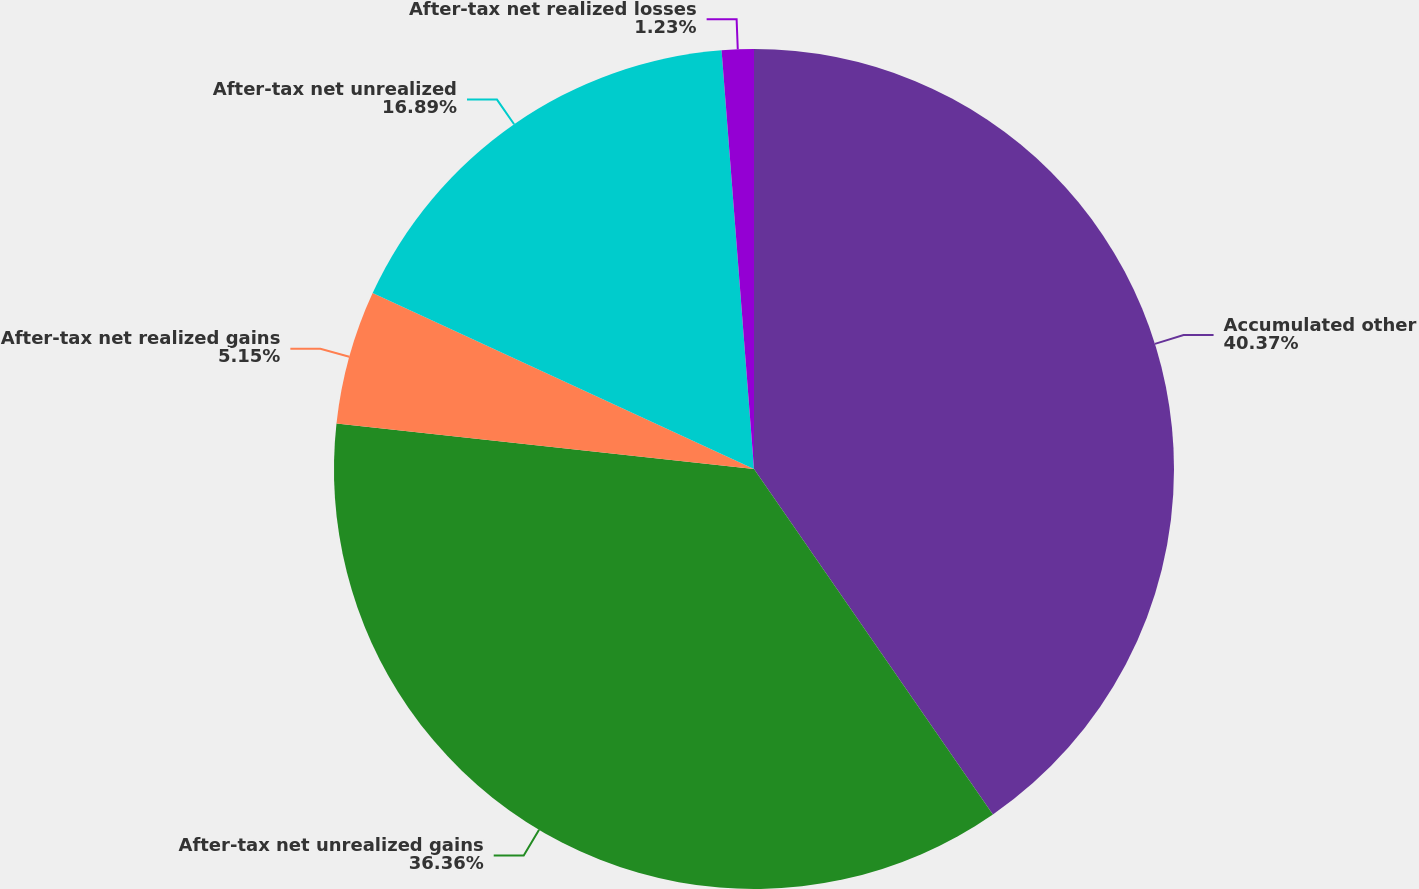Convert chart to OTSL. <chart><loc_0><loc_0><loc_500><loc_500><pie_chart><fcel>Accumulated other<fcel>After-tax net unrealized gains<fcel>After-tax net realized gains<fcel>After-tax net unrealized<fcel>After-tax net realized losses<nl><fcel>40.37%<fcel>36.36%<fcel>5.15%<fcel>16.89%<fcel>1.23%<nl></chart> 